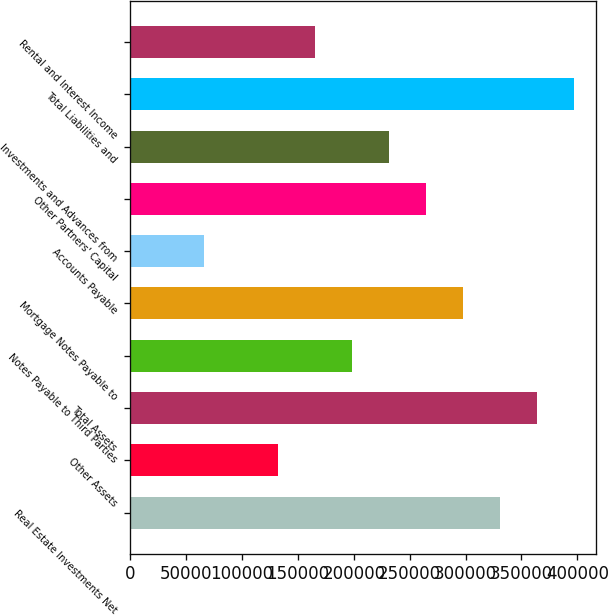Convert chart. <chart><loc_0><loc_0><loc_500><loc_500><bar_chart><fcel>Real Estate Investments Net<fcel>Other Assets<fcel>Total Assets<fcel>Notes Payable to Third Parties<fcel>Mortgage Notes Payable to<fcel>Accounts Payable<fcel>Other Partners' Capital<fcel>Investments and Advances from<fcel>Total Liabilities and<fcel>Rental and Interest Income<nl><fcel>330865<fcel>132438<fcel>363936<fcel>198581<fcel>297794<fcel>66296.2<fcel>264723<fcel>231652<fcel>397007<fcel>165510<nl></chart> 